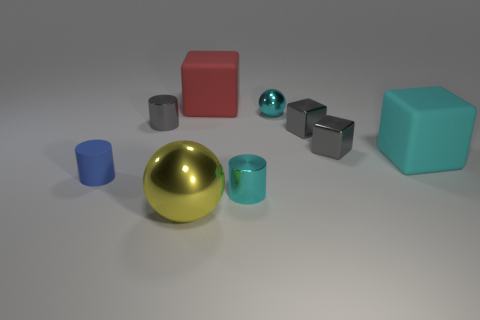Subtract 1 blocks. How many blocks are left? 3 Subtract all cylinders. How many objects are left? 6 Add 3 blocks. How many blocks exist? 7 Subtract 1 gray cylinders. How many objects are left? 8 Subtract all big purple spheres. Subtract all gray shiny blocks. How many objects are left? 7 Add 3 gray metal blocks. How many gray metal blocks are left? 5 